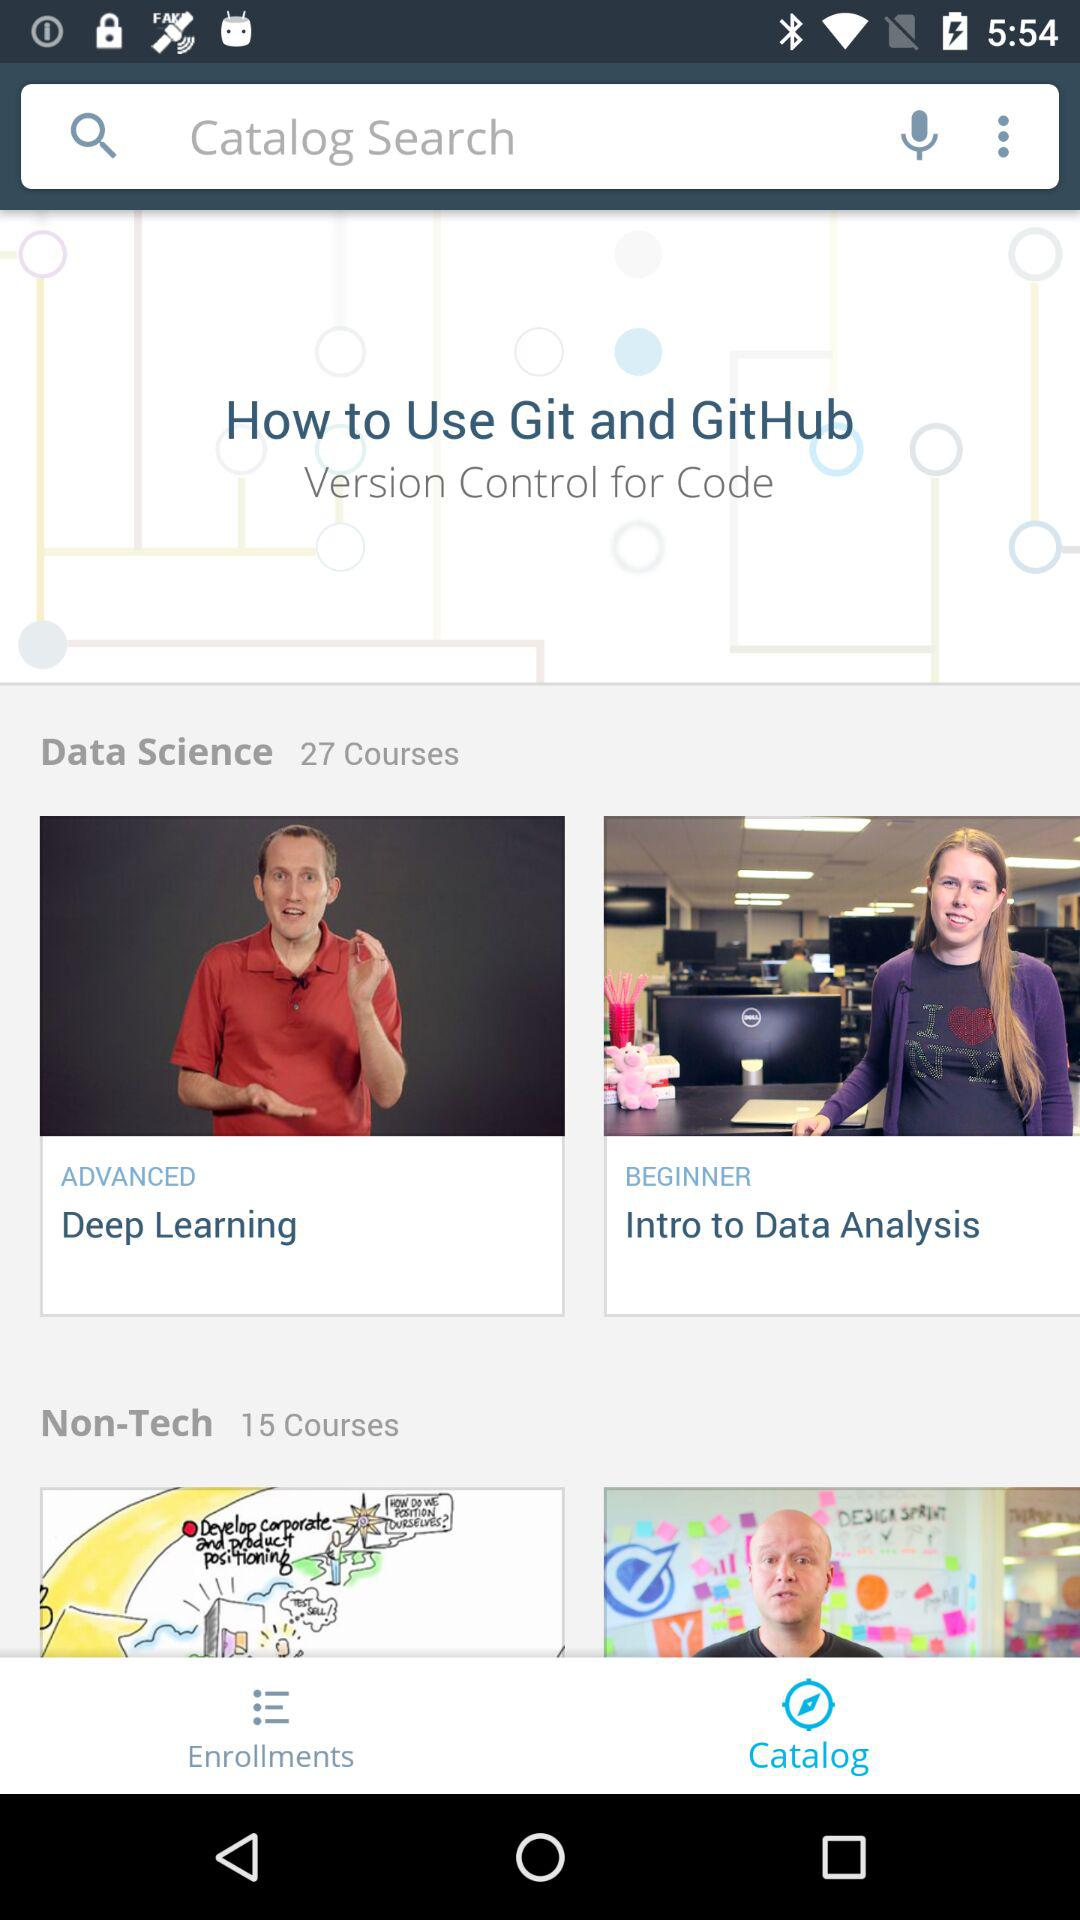How many more courses are in the Data Science category than the Non-Tech category?
Answer the question using a single word or phrase. 12 